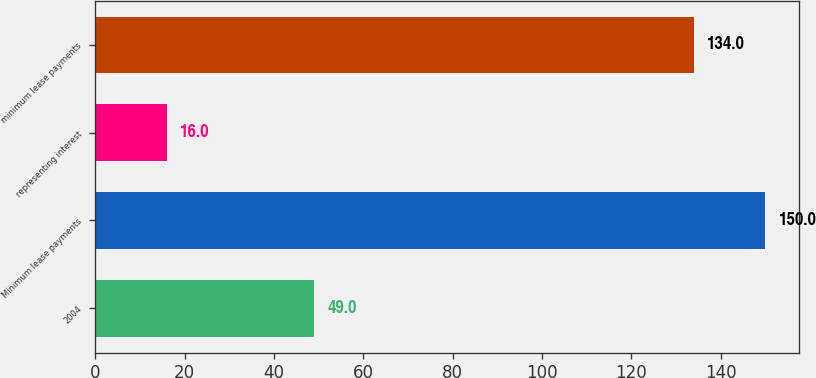Convert chart. <chart><loc_0><loc_0><loc_500><loc_500><bar_chart><fcel>2004<fcel>Minimum lease payments<fcel>representing interest<fcel>minimum lease payments<nl><fcel>49<fcel>150<fcel>16<fcel>134<nl></chart> 